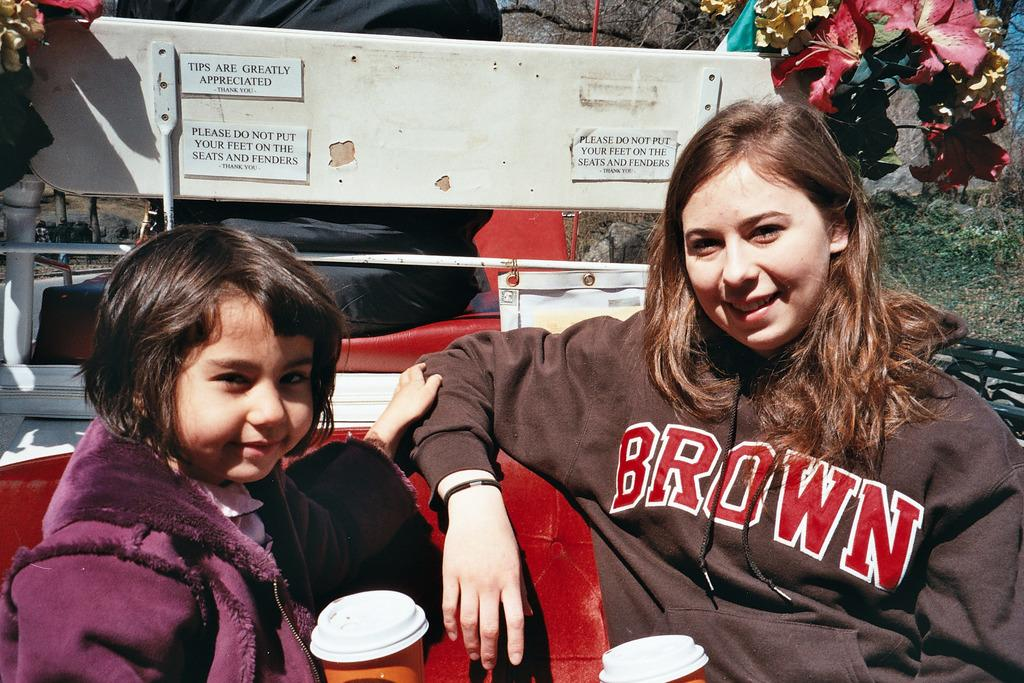Provide a one-sentence caption for the provided image. Two people are riding on the back of a vehicle, with her shirt saying BROWN and the sign saying TIPS ARE GREATLY APPRECIATED THANK YOU. 